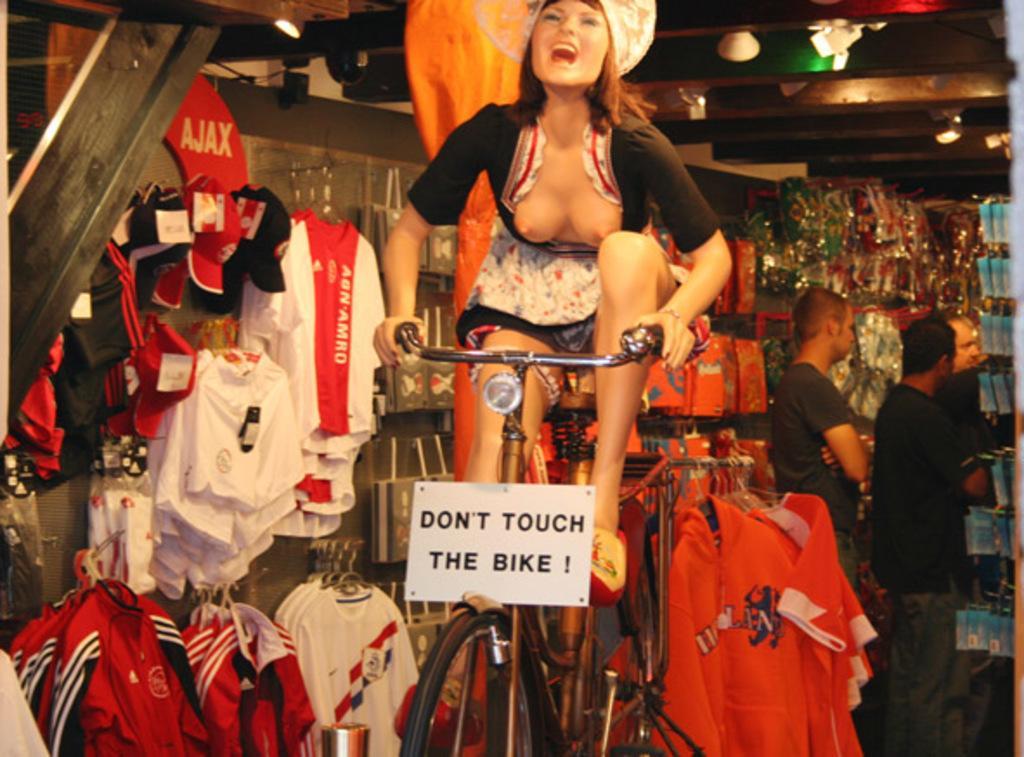Can you describe this image briefly? In this image I can see a woman is sitting on a cycle. In the background I can see few clothes and few more people. 